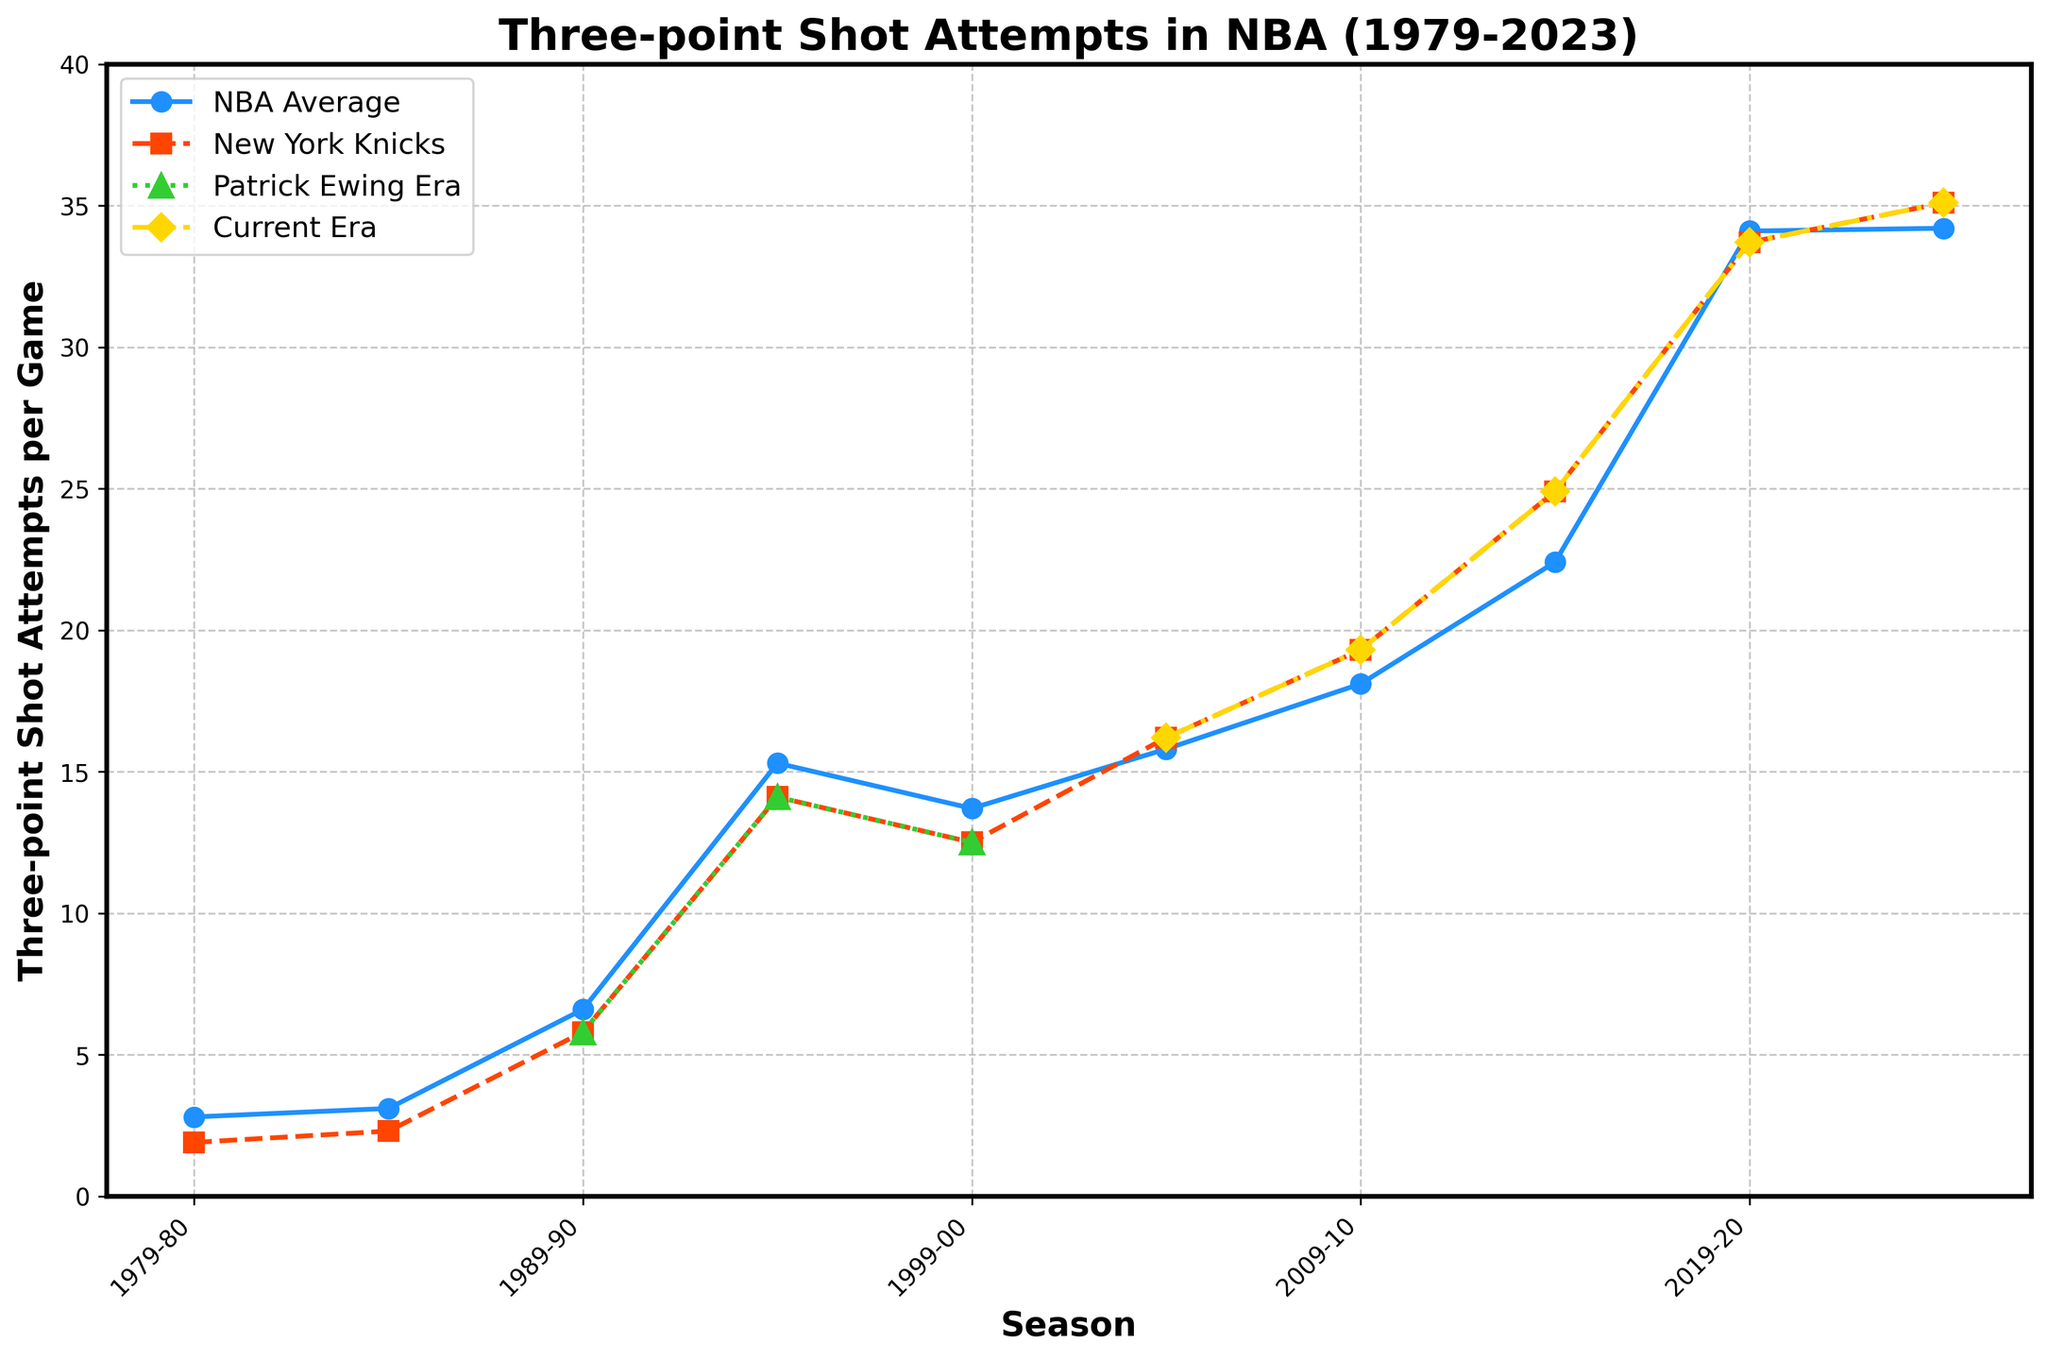What is the difference in the number of three-point shot attempts per game between the NBA average and the New York Knicks in the 2022-23 season? Identify the values for the NBA average and the New York Knicks by looking at the end of the plotted lines for 2022-23. The NBA average is 34.2 and the New York Knicks' value is 35.1. Subtract the NBA average from the New York Knicks' value: 35.1 - 34.2 = 0.9
Answer: 0.9 How much did the New York Knicks' three-point shot attempts per game increase from the Patrick Ewing Era (1994-95) to the current era (2022-23)? Locate the values for the New York Knicks in 1994-95 and 2022-23. The 1994-95 value is 14.1, and the 2022-23 value is 35.1. Subtract the 1994-95 value from the 2022-23 value: 35.1 - 14.1 = 21
Answer: 21 During which season did the NBA average for three-point shot attempts per game exceed 20 for the first time? Follow the NBA average line and look for the first season where the value exceeds 20. This is the 2014-15 season, where the value is 22.4
Answer: 2014-15 How does the number of three-point shot attempts per game by the New York Knicks in 2009-10 compare to the NBA average of the same season? Locate the values for both the New York Knicks and the NBA average for 2009-10. The NBA average is 18.1, and the New York Knicks' value is 19.3. Compare the two values: 19.3 > 18.1
Answer: The New York Knicks attempted more three-point shots (19.3) than the NBA average (18.1) in 2009-10 What is the combined average of three-point shot attempts per game for the New York Knicks in 1999-00 and 2004-05? Find the New York Knicks values for 1999-00 and 2004-05, which are 12.5 and 16.2 respectively. Calculate the average: (12.5 + 16.2) / 2 = 14.35
Answer: 14.35 By how much did the NBA average three-point shot attempts per game increase from 1984-85 to 1989-90? Locate the NBA average values for 1984-85 and 1989-90. The 1984-85 value is 3.1, and the 1989-90 value is 6.6. Subtract the 1984-85 value from the 1989-90 value: 6.6 - 3.1 = 3.5
Answer: 3.5 In which season did the New York Knicks have the highest number of three-point shot attempts per game, and what was the value? Identify the highest point in the New York Knicks line on the graph, which is in the 2022-23 season with a value of 35.1
Answer: 2022-23, 35.1 How does the rate of increase in three-point shot attempts per game from 2004-05 to 2009-10 compare between the NBA average and the New York Knicks? Locate the values for 2004-05 and 2009-10 for both the NBA average (15.8 to 18.1) and the New York Knicks (16.2 to 19.3). Calculate the difference: NBA average increase = 18.1 - 15.8 = 2.3; Knicks increase = 19.3 - 16.2 = 3.1. Compare the increases: 3.1 > 2.3
Answer: The rate of increase was higher for the New York Knicks (3.1) than for the NBA average (2.3) What are the visual trends for the Patrick Ewing Era and the Current Era in terms of growth in three-point shot attempts per game by the New York Knicks? The Patrick Ewing Era line is constant at 14.1 for 1994-95 and 12.5 from 1999-00. The Current Era line shows a consistent increase: from 16.2 in 2004-05 to 35.1 in 2022-23. Thus, there is no growth in the Patrick Ewing Era but a steep increasing trend in the Current Era.
Answer: Patrick Ewing Era: No growth; Current Era: Steep increase What is the visual difference in terms of color and line style between the NBA average and the New York Knicks in the plot? The NBA average is visualized with a blue solid line with circular markers, whereas the New York Knicks are represented with an orange dashed line with square markers
Answer: Blue solid line with circles (NBA average) vs. Orange dashed line with squares (Knicks) 